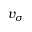Convert formula to latex. <formula><loc_0><loc_0><loc_500><loc_500>v _ { \sigma }</formula> 